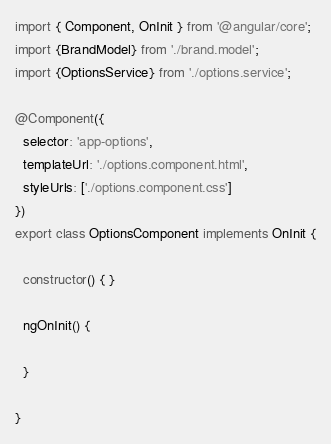<code> <loc_0><loc_0><loc_500><loc_500><_TypeScript_>import { Component, OnInit } from '@angular/core';
import {BrandModel} from './brand.model';
import {OptionsService} from './options.service';

@Component({
  selector: 'app-options',
  templateUrl: './options.component.html',
  styleUrls: ['./options.component.css']
})
export class OptionsComponent implements OnInit {

  constructor() { }

  ngOnInit() {

  }

}
</code> 